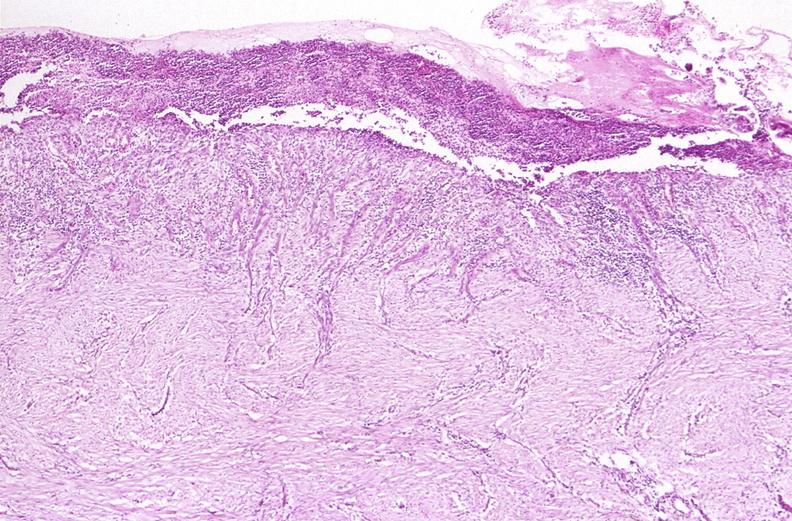does this image show stomach, chronic peptic ulcer?
Answer the question using a single word or phrase. Yes 